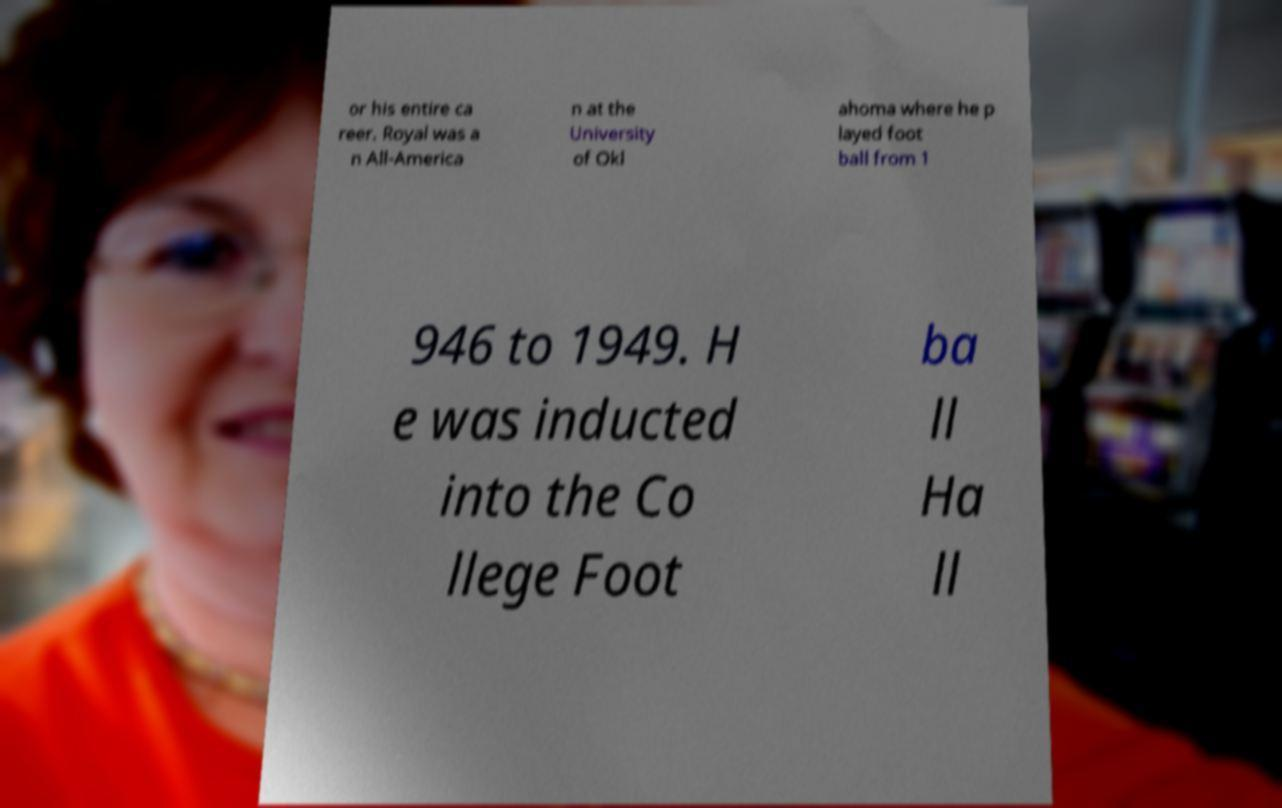Please read and relay the text visible in this image. What does it say? or his entire ca reer. Royal was a n All-America n at the University of Okl ahoma where he p layed foot ball from 1 946 to 1949. H e was inducted into the Co llege Foot ba ll Ha ll 